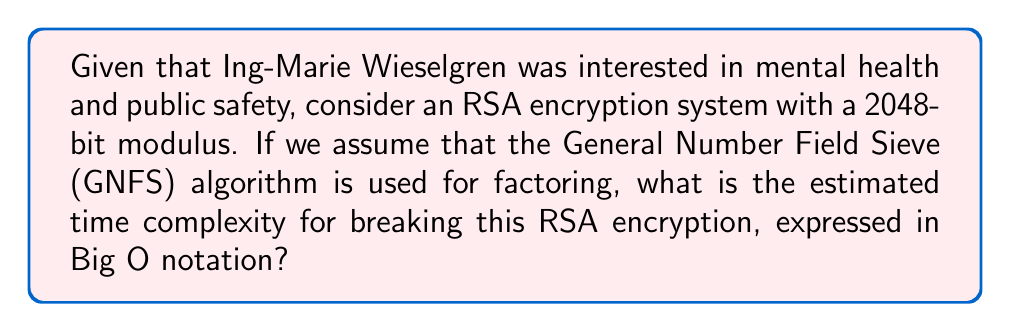Teach me how to tackle this problem. To analyze the computational complexity of factoring large prime numbers for RSA encryption, we need to consider the following steps:

1. RSA security relies on the difficulty of factoring the product of two large prime numbers.

2. The General Number Field Sieve (GNFS) is currently the most efficient algorithm for factoring large integers.

3. The time complexity of GNFS for a number $n$ is approximately:

   $$O(\exp((c + o(1))(\ln n)^{1/3}(\ln \ln n)^{2/3}))$$

   where $c$ is a constant approximately equal to $(64/9)^{1/3} \approx 1.923$.

4. For a 2048-bit RSA modulus, $n$ is approximately $2^{2048}$.

5. Substituting this into the complexity formula:

   $$O(\exp((1.923 + o(1))(\ln 2^{2048})^{1/3}(\ln \ln 2^{2048})^{2/3}))$$

6. Simplify:
   $$O(\exp((1.923 + o(1))(2048 \ln 2)^{1/3}(\ln(2048 \ln 2))^{2/3}))$$

7. This can be further simplified to:

   $$O(\exp((1.923 + o(1))(1419.86)^{1/3}(7.62)^{2/3}))$$

8. Evaluating this expression gives us an approximate time complexity of:

   $$O(\exp(64.24 + o(1)))$$

This complexity is often referred to as "sub-exponential" because it grows faster than any polynomial function but slower than a full exponential function.
Answer: $O(\exp(64.24 + o(1)))$ 